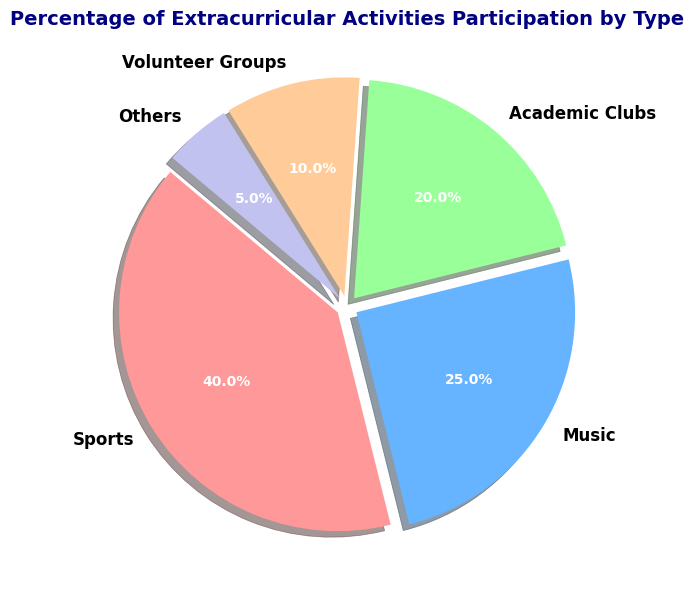What percentage of students participate in Sports? Look at the slice labeled 'Sports' and find its corresponding percentage, which is indicated on the chart.
Answer: 40% Which extracurricular activity has the lowest participation rate? Compare the percentages of all the extracurricular activities and find the one with the smallest percentage.
Answer: Others What is the combined percentage of students participating in Music and Academic Clubs? Add the percentages of Music and Academic Clubs: 25% + 20% = 45%.
Answer: 45% Is the participation in Sports higher than the combined participation in Volunteer Groups and Others? First, add the percentages for Volunteer Groups and Others: 10% + 5% = 15%. Then compare this with the percentage of Sports, which is 40%, and check if 40% > 15%.
Answer: Yes What is the difference in participation rate between Sports and Music? Subtract the percentage of Music from the percentage of Sports: 40% - 25% = 15%.
Answer: 15% How much more popular are Sports compared to Academic Clubs? Subtract the percentage of Academic Clubs from the percentage of Sports: 40% - 20% = 20%.
Answer: 20% What percentage of students do not participate in either Sports or Music? Add the percentages of Sports and Music to find the combined participation: 40% + 25% = 65%. Then subtract this from 100% to find those not in Sports or Music: 100% - 65% = 35%.
Answer: 35% Which two activities have the closest participation rates, and what is their difference? Compare the differences between each pair of activities. Academic Clubs and Volunteer Groups have the closest rates with a difference of 20% - 10% = 10%.
Answer: Academic Clubs and Volunteer Groups; 10% Which category uses the green color? Identify the piece of the pie chart colored in green and check its label.
Answer: Academic Clubs How many types of extracurricular activities have a participation rate above 20%? Identify and count the slices with percentages greater than 20%: Sports (40%) and Music (25%).
Answer: Two 